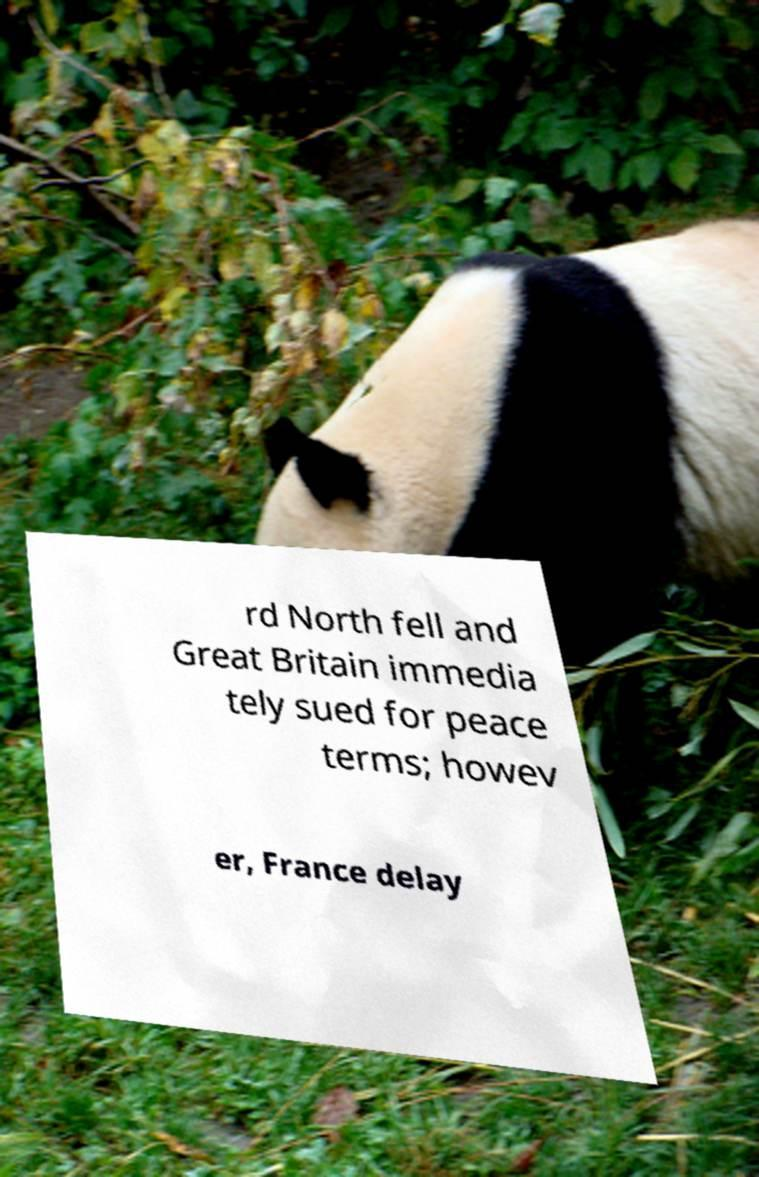There's text embedded in this image that I need extracted. Can you transcribe it verbatim? rd North fell and Great Britain immedia tely sued for peace terms; howev er, France delay 